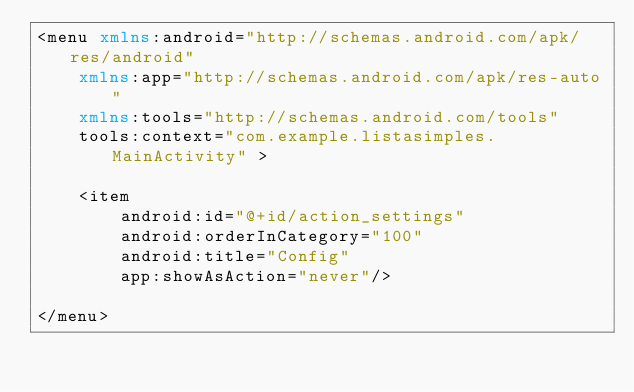Convert code to text. <code><loc_0><loc_0><loc_500><loc_500><_XML_><menu xmlns:android="http://schemas.android.com/apk/res/android"
    xmlns:app="http://schemas.android.com/apk/res-auto"
    xmlns:tools="http://schemas.android.com/tools"
    tools:context="com.example.listasimples.MainActivity" >

    <item
        android:id="@+id/action_settings"
        android:orderInCategory="100"
        android:title="Config"
        app:showAsAction="never"/>

</menu>
</code> 